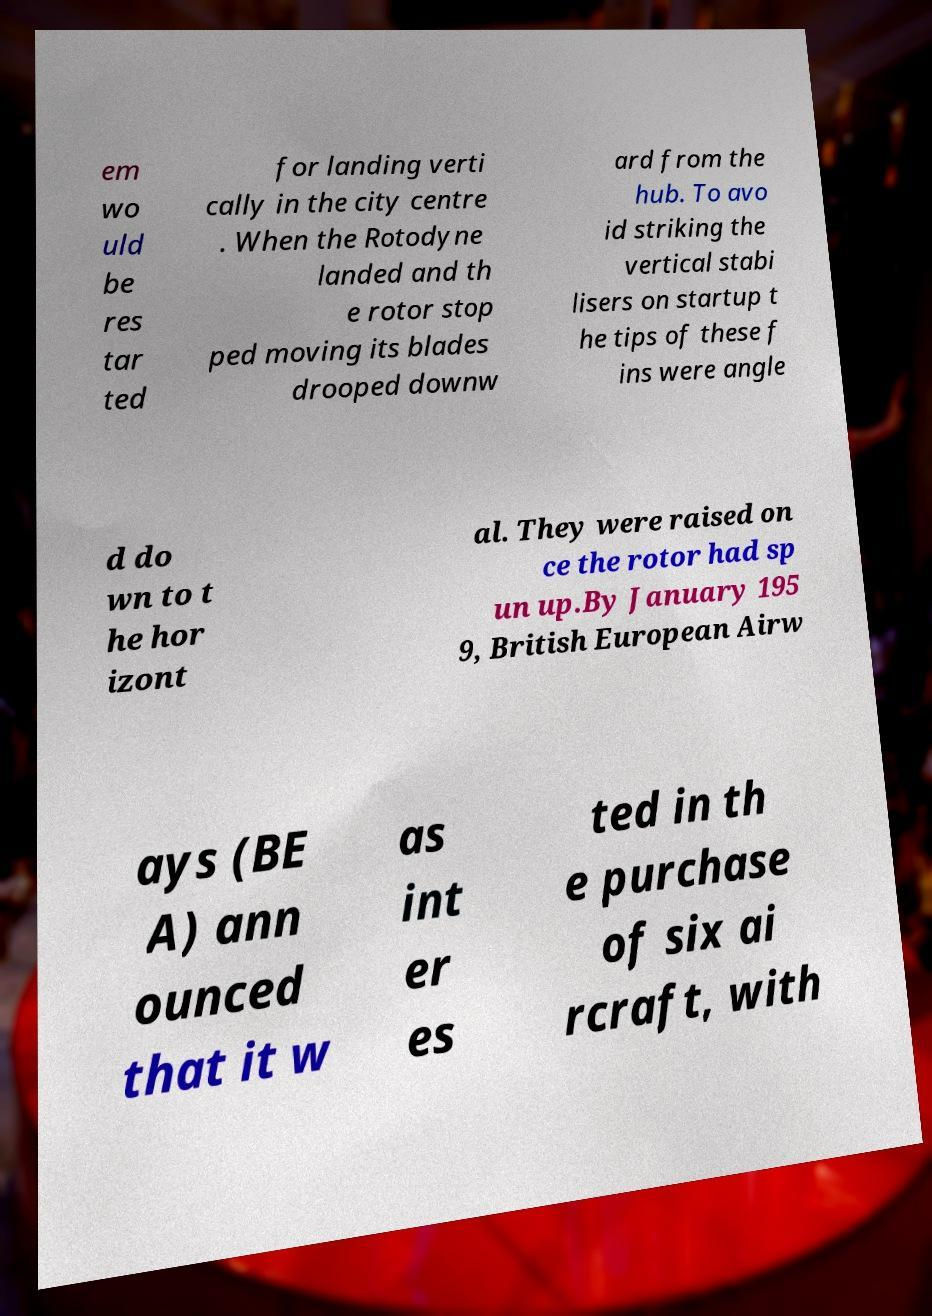Could you assist in decoding the text presented in this image and type it out clearly? em wo uld be res tar ted for landing verti cally in the city centre . When the Rotodyne landed and th e rotor stop ped moving its blades drooped downw ard from the hub. To avo id striking the vertical stabi lisers on startup t he tips of these f ins were angle d do wn to t he hor izont al. They were raised on ce the rotor had sp un up.By January 195 9, British European Airw ays (BE A) ann ounced that it w as int er es ted in th e purchase of six ai rcraft, with 